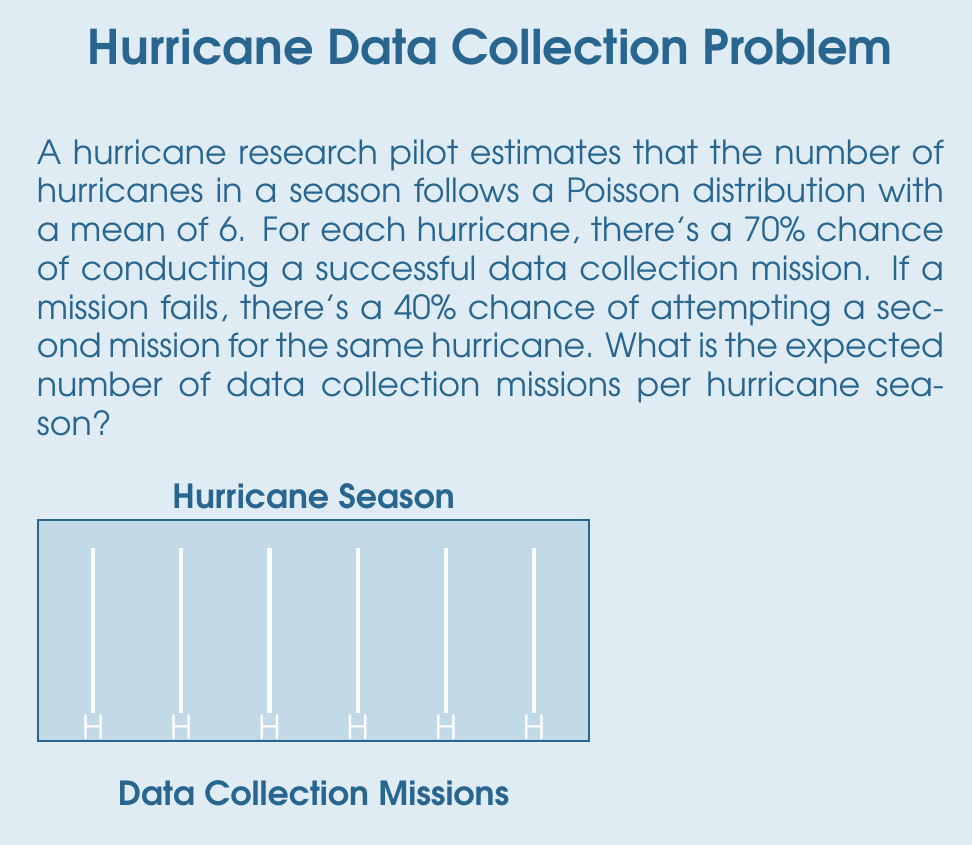Solve this math problem. Let's approach this step-by-step:

1) First, we need to calculate the expected number of missions per hurricane:
   - Probability of one successful mission: 0.7
   - Probability of failed first mission and successful second: 0.3 * 0.4 = 0.12
   - Expected missions per hurricane: $E[M] = 0.7 + 2(0.12) = 0.94$

2) Now, let's consider the number of hurricanes. The number of hurricanes follows a Poisson distribution with mean $\lambda = 6$.

3) We can use the property of linearity of expectation. If $X$ is the number of hurricanes and $M_i$ is the number of missions for the $i$-th hurricane, then:

   $E[\text{total missions}] = E[M_1 + M_2 + ... + M_X] = E[X] \cdot E[M]$

4) For a Poisson distribution, $E[X] = \lambda = 6$

5) Therefore, the expected number of missions per season is:

   $E[\text{total missions}] = 6 \cdot 0.94 = 5.64$

Thus, the pilot can expect to conduct about 5.64 data collection missions per hurricane season on average.
Answer: 5.64 missions 